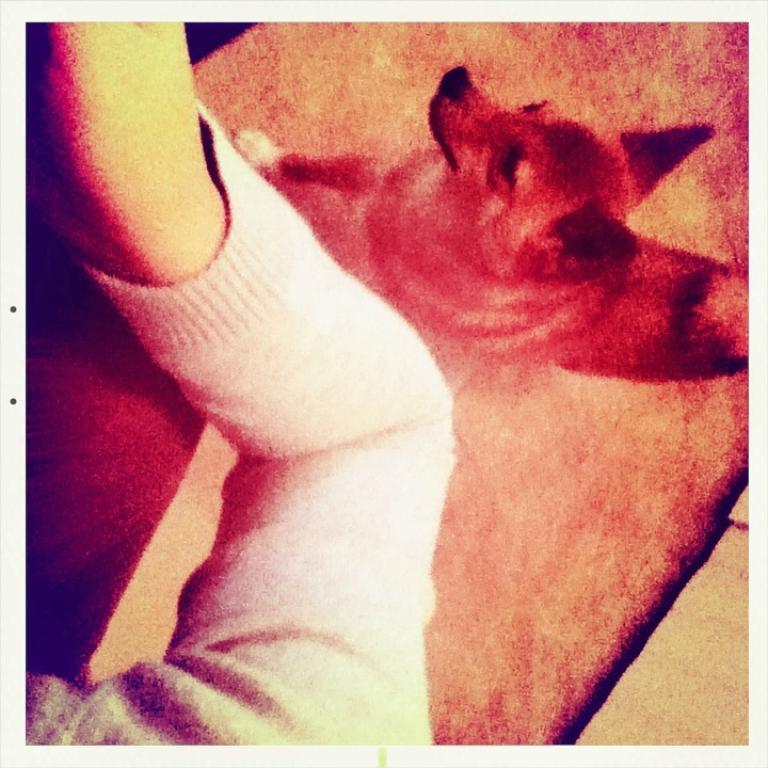What type of animal is in the image? There is a dog in the image. What can be seen on the left side of the image? There is a hand with a white cloth on the left side of the image. What type of jelly can be seen on the dog's fur in the image? There is no jelly present on the dog's fur in the image. What is the texture of the flock in the image? There is no flock present in the image. 